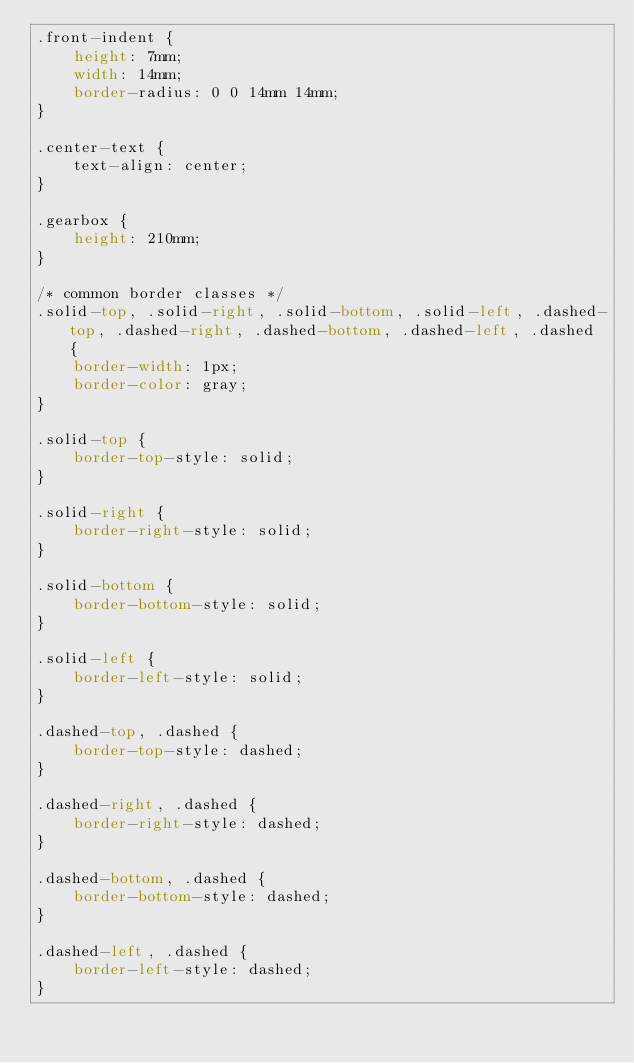Convert code to text. <code><loc_0><loc_0><loc_500><loc_500><_CSS_>.front-indent {
    height: 7mm; 
    width: 14mm; 
    border-radius: 0 0 14mm 14mm;
}

.center-text {
    text-align: center;
}

.gearbox {
    height: 210mm;
}

/* common border classes */
.solid-top, .solid-right, .solid-bottom, .solid-left, .dashed-top, .dashed-right, .dashed-bottom, .dashed-left, .dashed {
    border-width: 1px;
    border-color: gray;
}

.solid-top {
    border-top-style: solid;
}

.solid-right {
    border-right-style: solid;
}

.solid-bottom {
    border-bottom-style: solid;
}

.solid-left {
    border-left-style: solid;
}

.dashed-top, .dashed {
    border-top-style: dashed;
}

.dashed-right, .dashed {
    border-right-style: dashed;
}

.dashed-bottom, .dashed {
    border-bottom-style: dashed;
}

.dashed-left, .dashed {
    border-left-style: dashed;
}</code> 